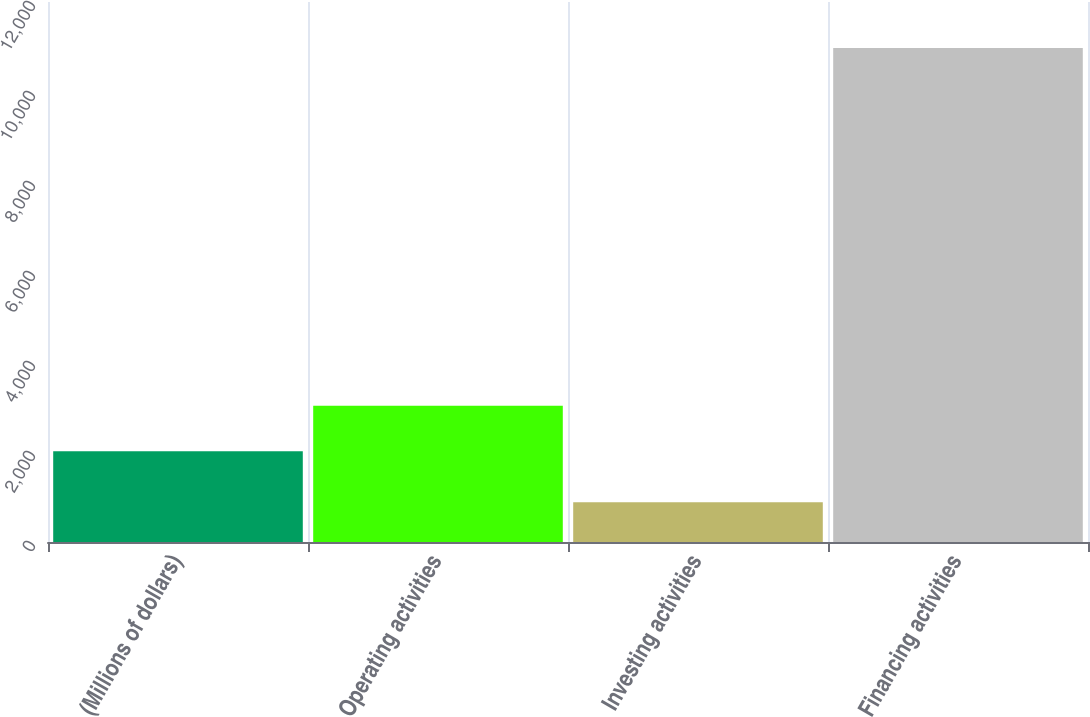Convert chart. <chart><loc_0><loc_0><loc_500><loc_500><bar_chart><fcel>(Millions of dollars)<fcel>Operating activities<fcel>Investing activities<fcel>Financing activities<nl><fcel>2017<fcel>3026.4<fcel>883<fcel>10977<nl></chart> 